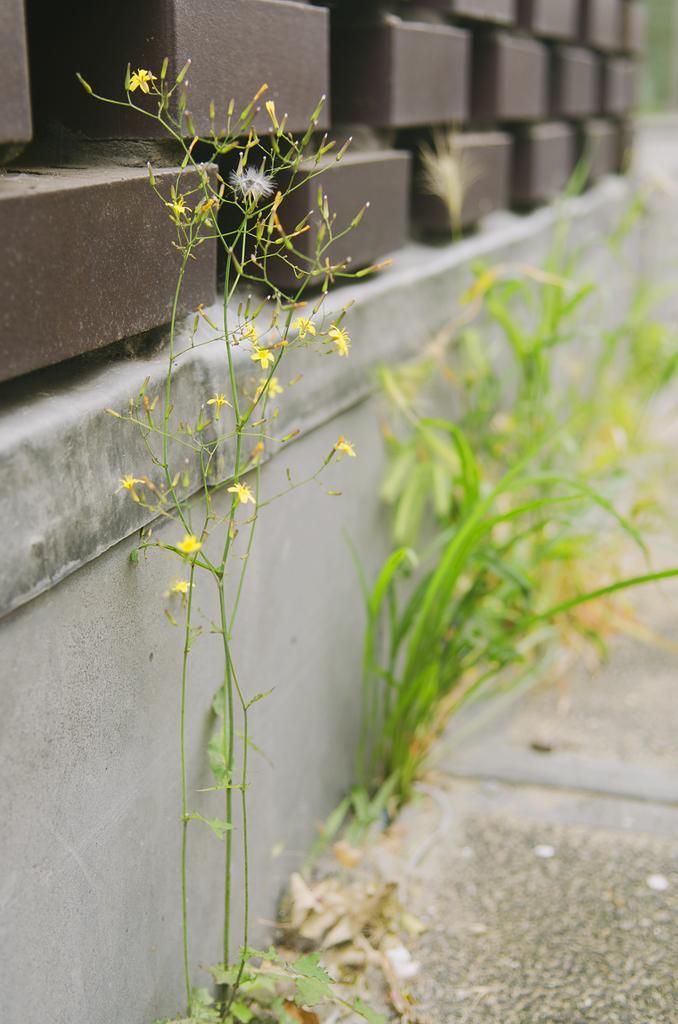Can you describe this image briefly? In this image there is a plant with yellow color flowers, and at the background there is grass, wall, bricks. 